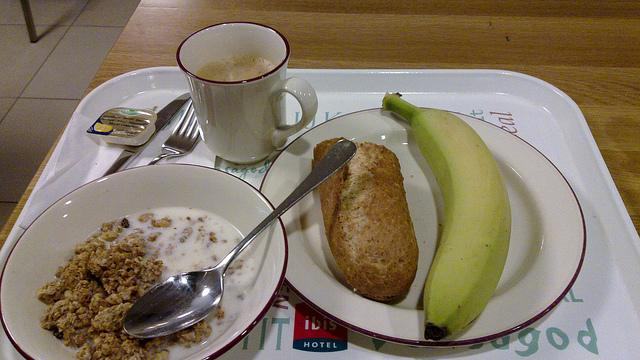What is on the plate all the way to the right?

Choices:
A) banana
B) egg
C) apple
D) lemon banana 